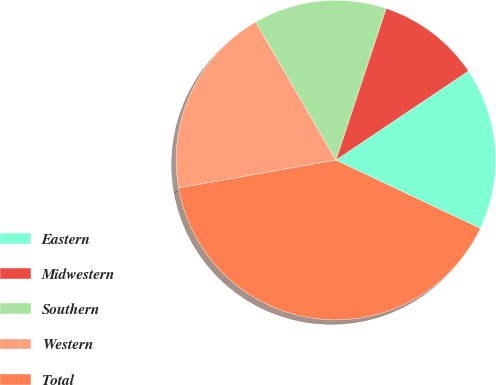Convert chart. <chart><loc_0><loc_0><loc_500><loc_500><pie_chart><fcel>Eastern<fcel>Midwestern<fcel>Southern<fcel>Western<fcel>Total<nl><fcel>16.44%<fcel>10.5%<fcel>13.47%<fcel>19.41%<fcel>40.19%<nl></chart> 